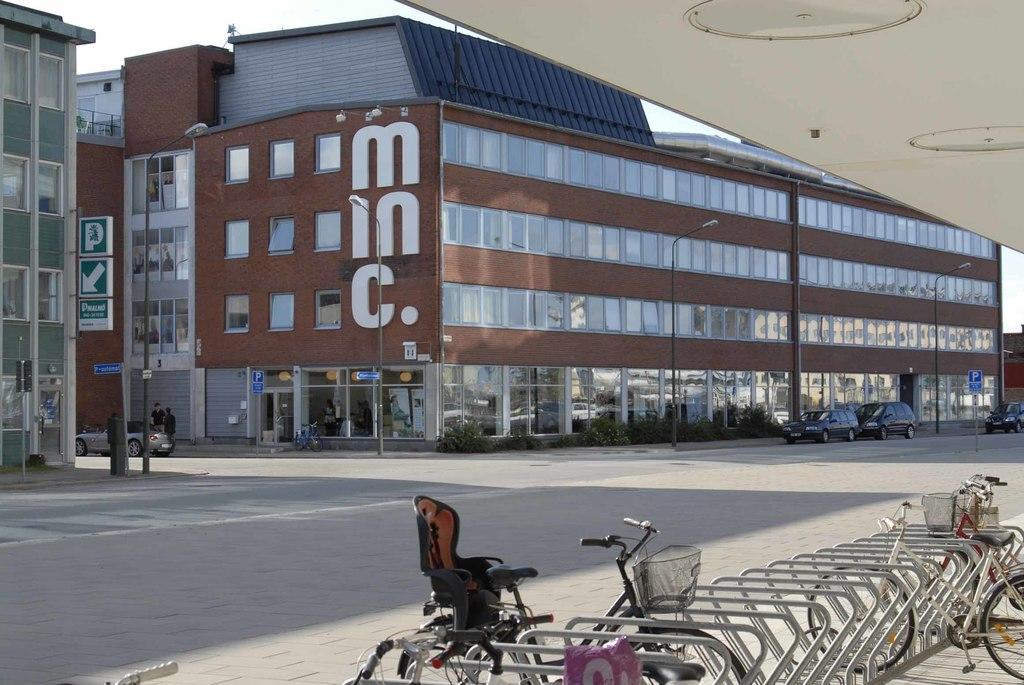Describe this image in one or two sentences. In this image we can see buildings, street lights, street poles, sign boards, motor vehicles on the road, persons standing on the road and bicycles in the bicycle stand. 